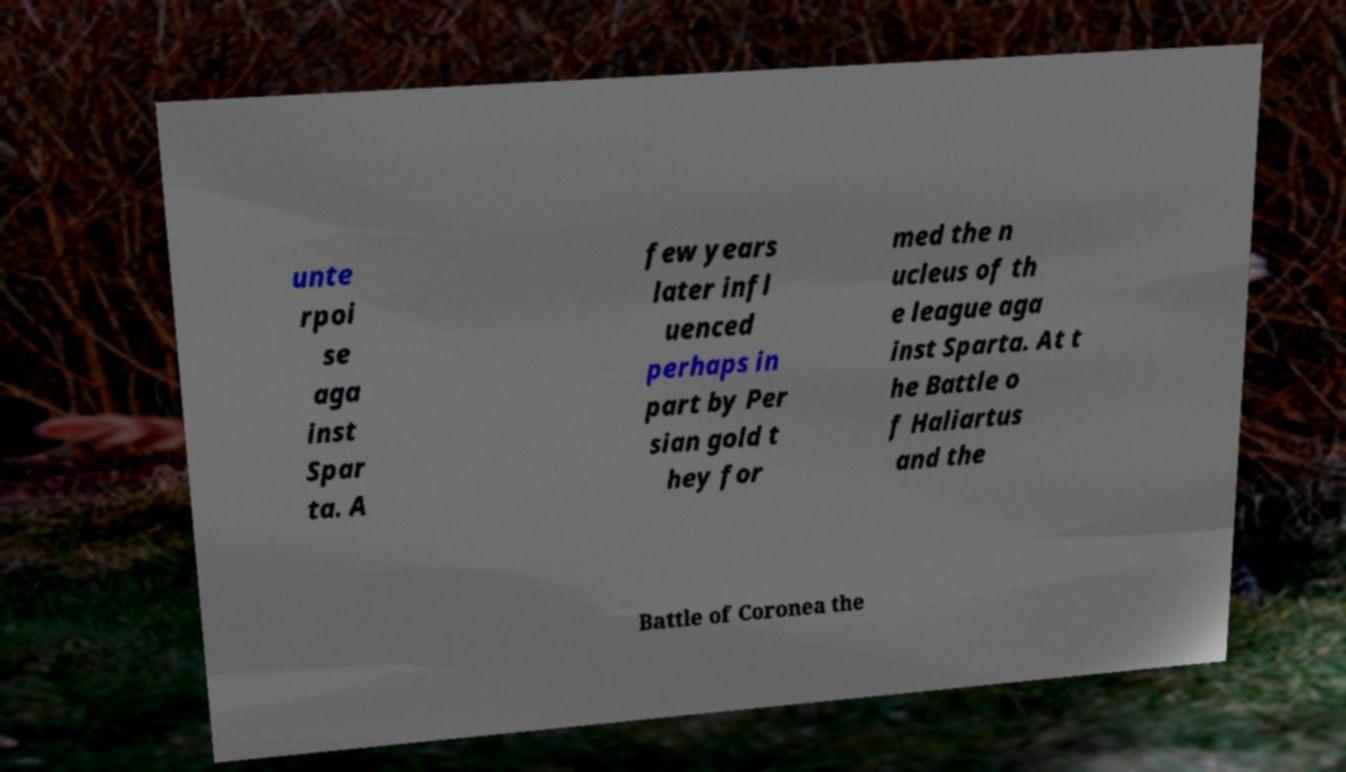Could you extract and type out the text from this image? unte rpoi se aga inst Spar ta. A few years later infl uenced perhaps in part by Per sian gold t hey for med the n ucleus of th e league aga inst Sparta. At t he Battle o f Haliartus and the Battle of Coronea the 